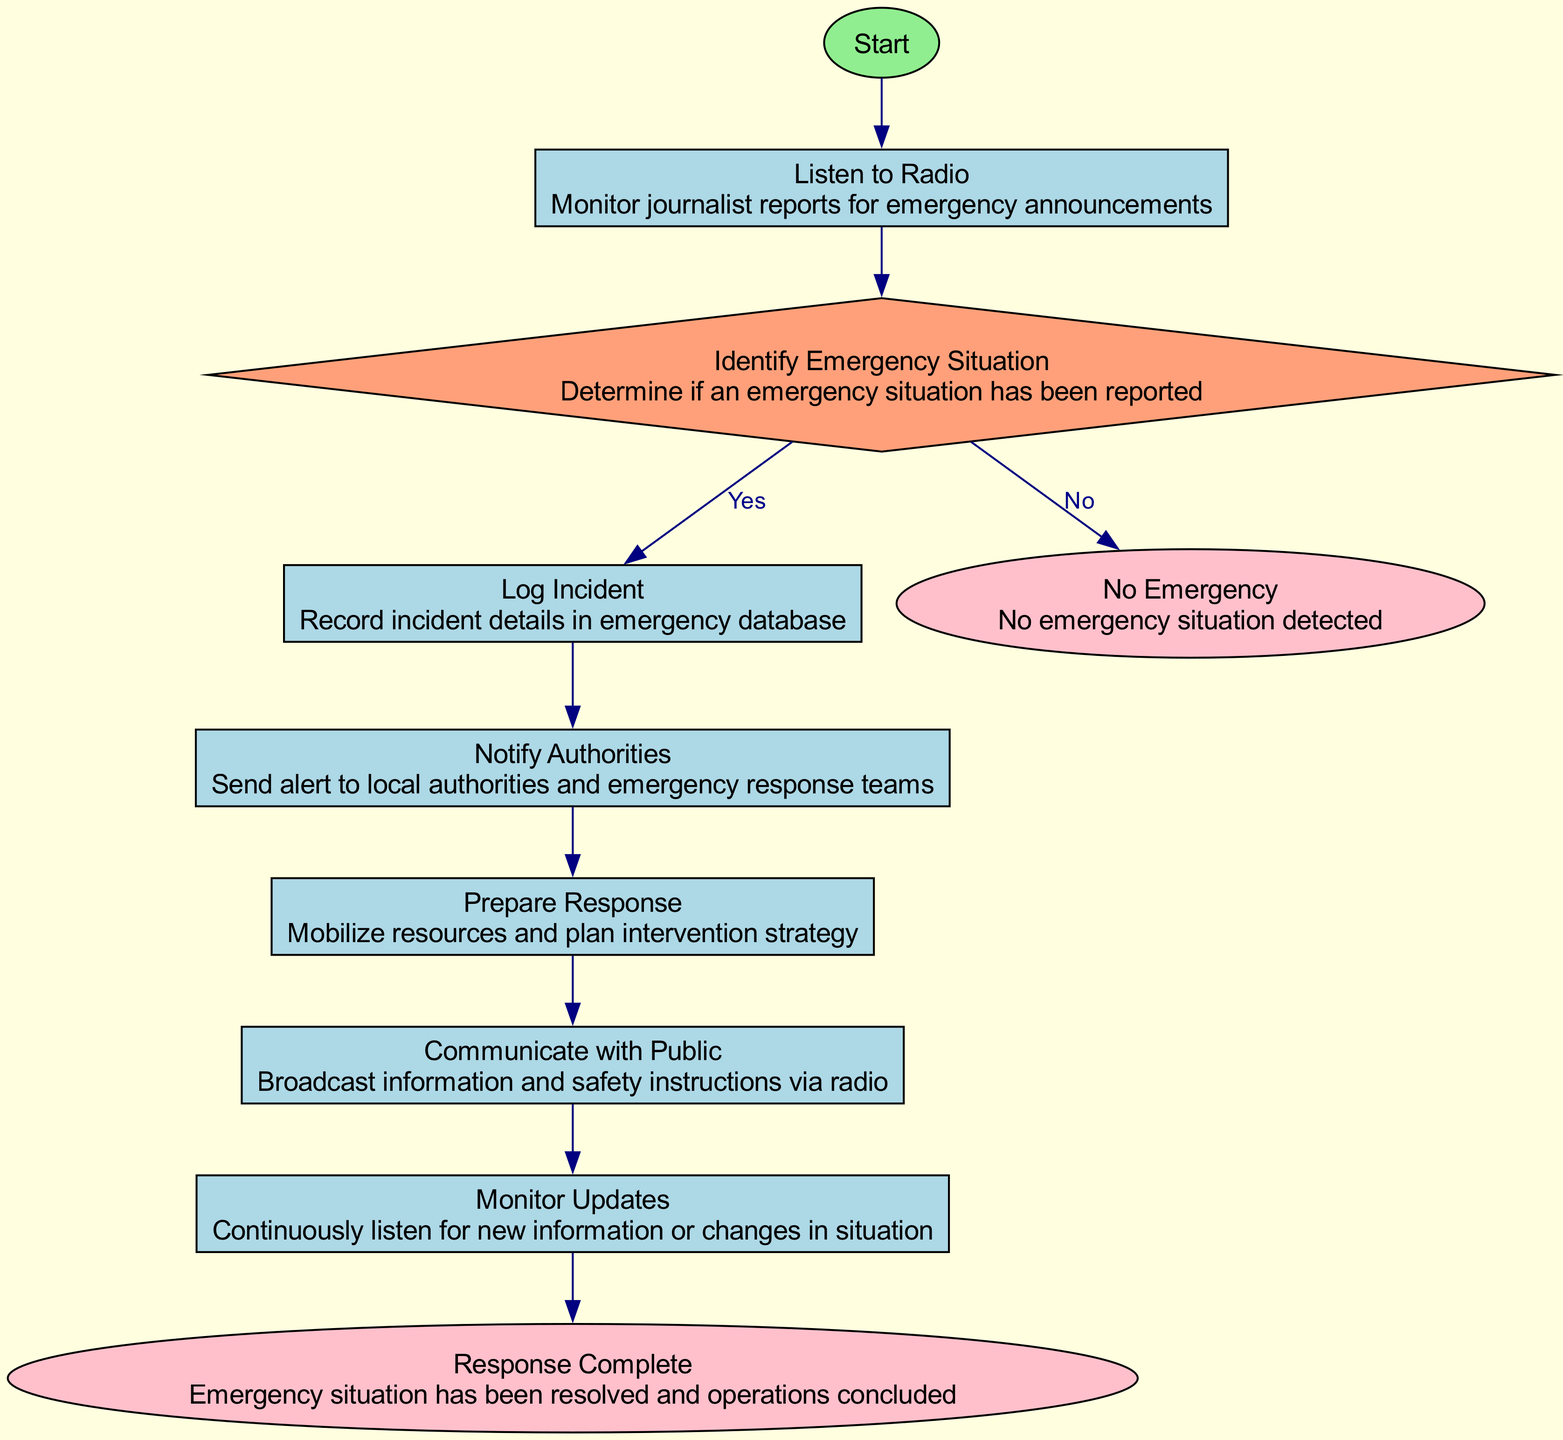What is the first action in the flowchart? The flowchart begins with the "Start" node, which indicates the initiation of the process. The first action flows from this node to listening to the radio.
Answer: Start How many decision points are present in the diagram? The diagram includes one decision point, which is "Identify Emergency Situation." This is where the flow diverges based on whether an emergency has been reported or not.
Answer: One What is the outcome if no emergency situation is detected? If no emergency is identified, the flow proceeds to the "No Emergency" end node, indicating the conclusion without any further actions required.
Answer: No Emergency What action follows "Log Incident"? After logging the incident details in the emergency database, the next action is to "Notify Authorities," where alerts are sent to appropriate response teams.
Answer: Notify Authorities What is the last action before concluding the response? The final action before concluding the response is "Monitor Updates," where continuous listening for new information takes place until the situation is resolved.
Answer: Monitor Updates What happens when an emergency situation is identified? When an emergency is identified, the flowchart indicates that the next step is to log the incident, ensuring the details are recorded for further actions.
Answer: Log Incident How many process actions are there in total? The diagram contains five process actions: "Listen to Radio," "Log Incident," "Notify Authorities," "Prepare Response," and "Communicate with Public."
Answer: Five What do you do after communicating with the public? After communicating safety instructions to the public, the next step is to "Monitor Updates," which involves listening for new information about the emergency situation.
Answer: Monitor Updates 